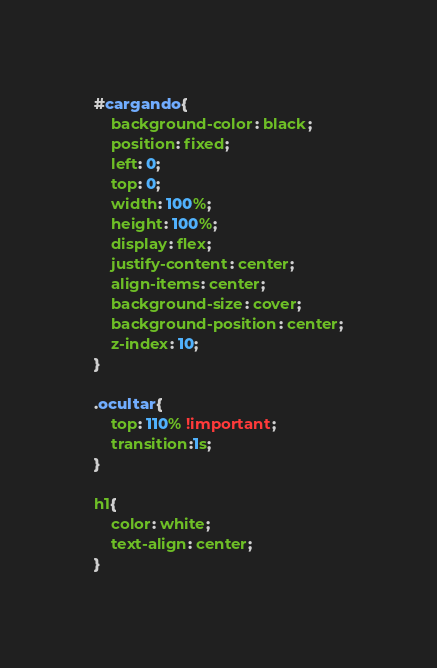Convert code to text. <code><loc_0><loc_0><loc_500><loc_500><_CSS_>#cargando{
    background-color: black;
    position: fixed;
    left: 0;
    top: 0;
    width: 100%;
    height: 100%;
    display: flex;
    justify-content: center;
    align-items: center;
    background-size: cover;
    background-position: center;
    z-index: 10;
}

.ocultar{
    top: 110% !important;
    transition:1s;
}

h1{
    color: white;
    text-align: center;
}</code> 